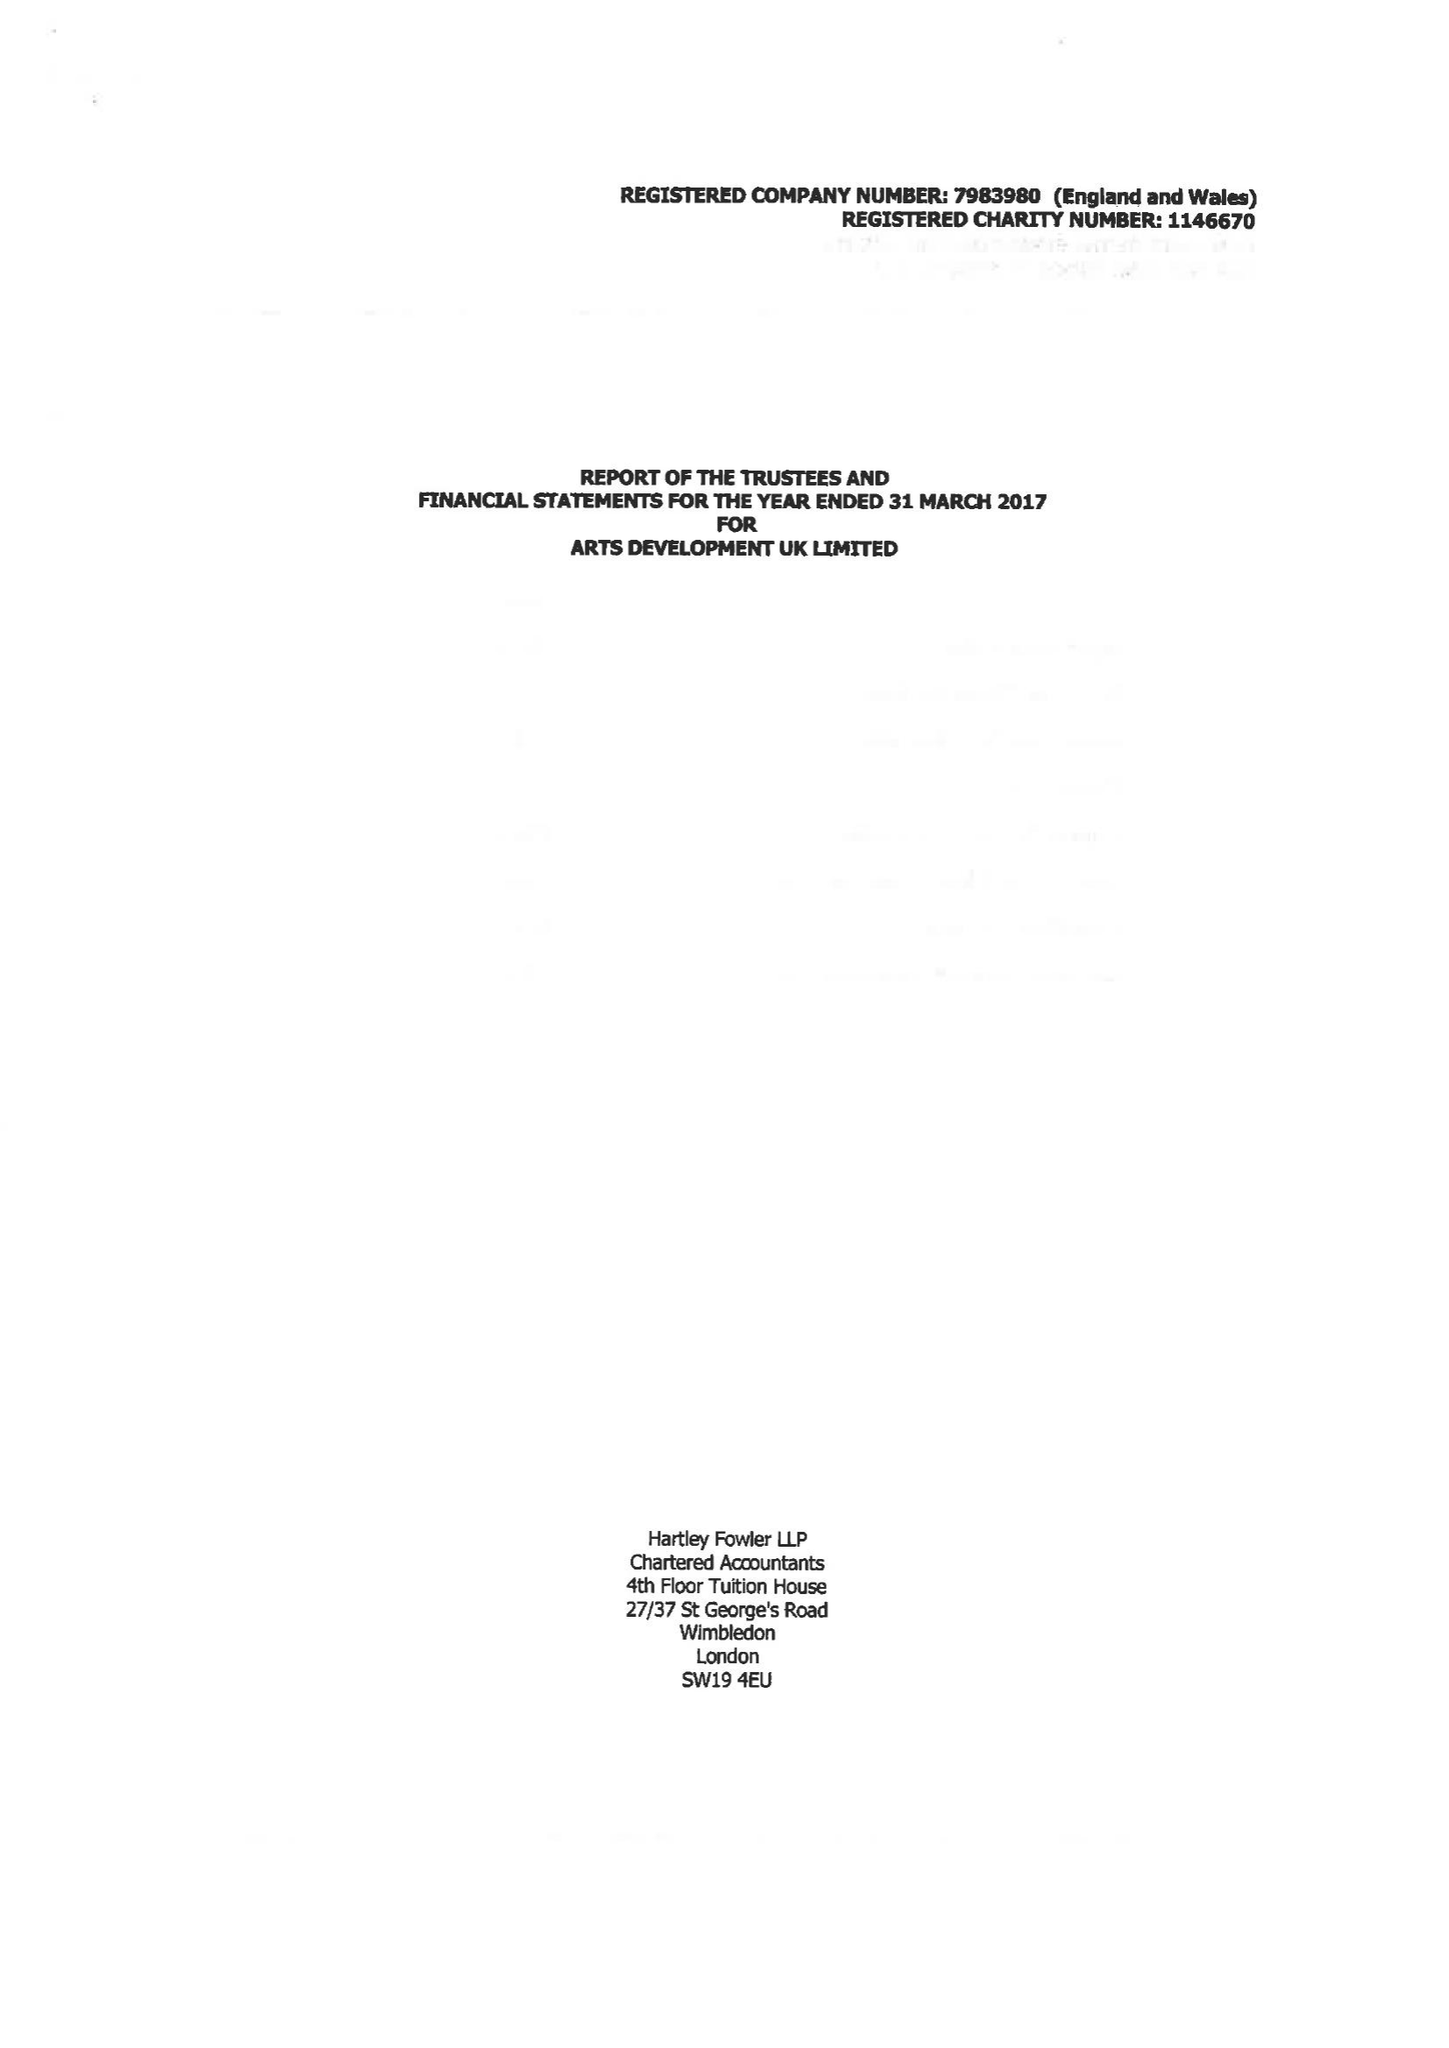What is the value for the address__street_line?
Answer the question using a single word or phrase. AMMANFORD 